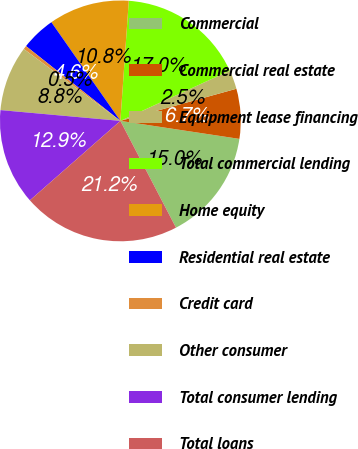Convert chart to OTSL. <chart><loc_0><loc_0><loc_500><loc_500><pie_chart><fcel>Commercial<fcel>Commercial real estate<fcel>Equipment lease financing<fcel>Total commercial lending<fcel>Home equity<fcel>Residential real estate<fcel>Credit card<fcel>Other consumer<fcel>Total consumer lending<fcel>Total loans<nl><fcel>14.97%<fcel>6.69%<fcel>2.55%<fcel>17.04%<fcel>10.83%<fcel>4.62%<fcel>0.48%<fcel>8.76%<fcel>12.9%<fcel>21.18%<nl></chart> 